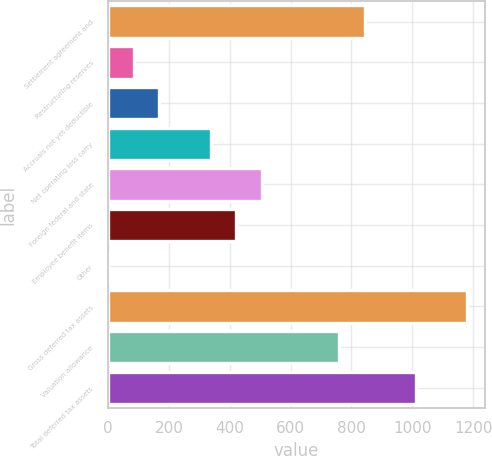Convert chart to OTSL. <chart><loc_0><loc_0><loc_500><loc_500><bar_chart><fcel>Settlement agreement and<fcel>Restructuring reserves<fcel>Accruals not yet deductible<fcel>Net operating loss carry<fcel>Foreign federal and state<fcel>Employee benefit items<fcel>Other<fcel>Gross deferred tax assets<fcel>Valuation allowance<fcel>Total deferred tax assets<nl><fcel>843<fcel>84.57<fcel>168.84<fcel>337.38<fcel>505.92<fcel>421.65<fcel>0.3<fcel>1180.08<fcel>758.73<fcel>1011.54<nl></chart> 